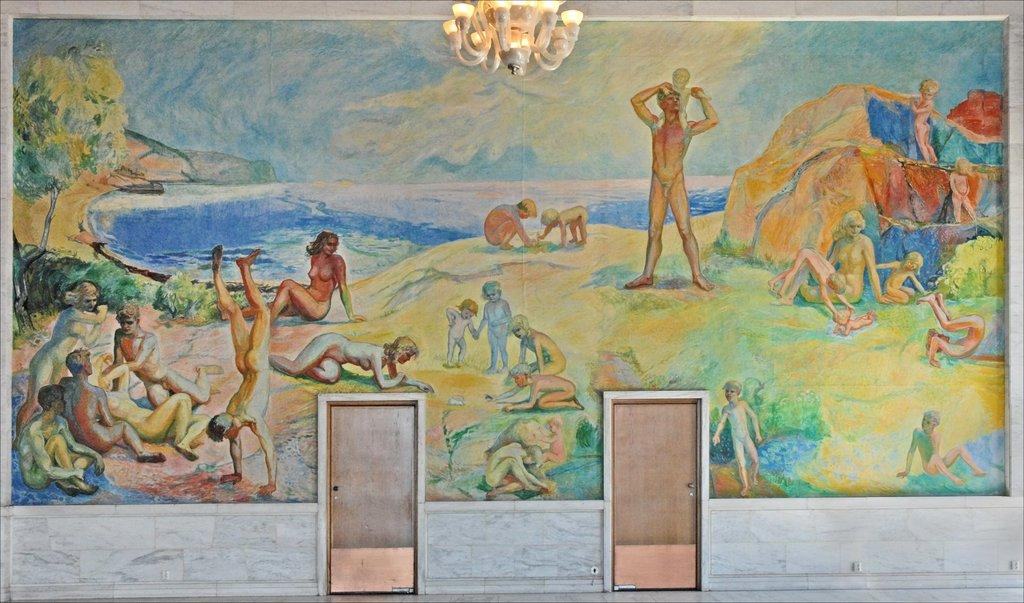What is the main subject of the painting? The painting contains many people. What natural element is depicted in the painting? There is water depicted in the painting. What type of vegetation is present in the painting? Trees are present in the painting. What geological feature is visible in the painting? Rocks are visible in the painting. What source of illumination is depicted in the painting? Lights are depicted in the painting. Is there any architectural feature in the painting? Yes, there is a door in the painting. What type of gold jewelry is worn by the person in the painting? There is no gold jewelry or person mentioned in the provided facts, so it cannot be determined from the image. 